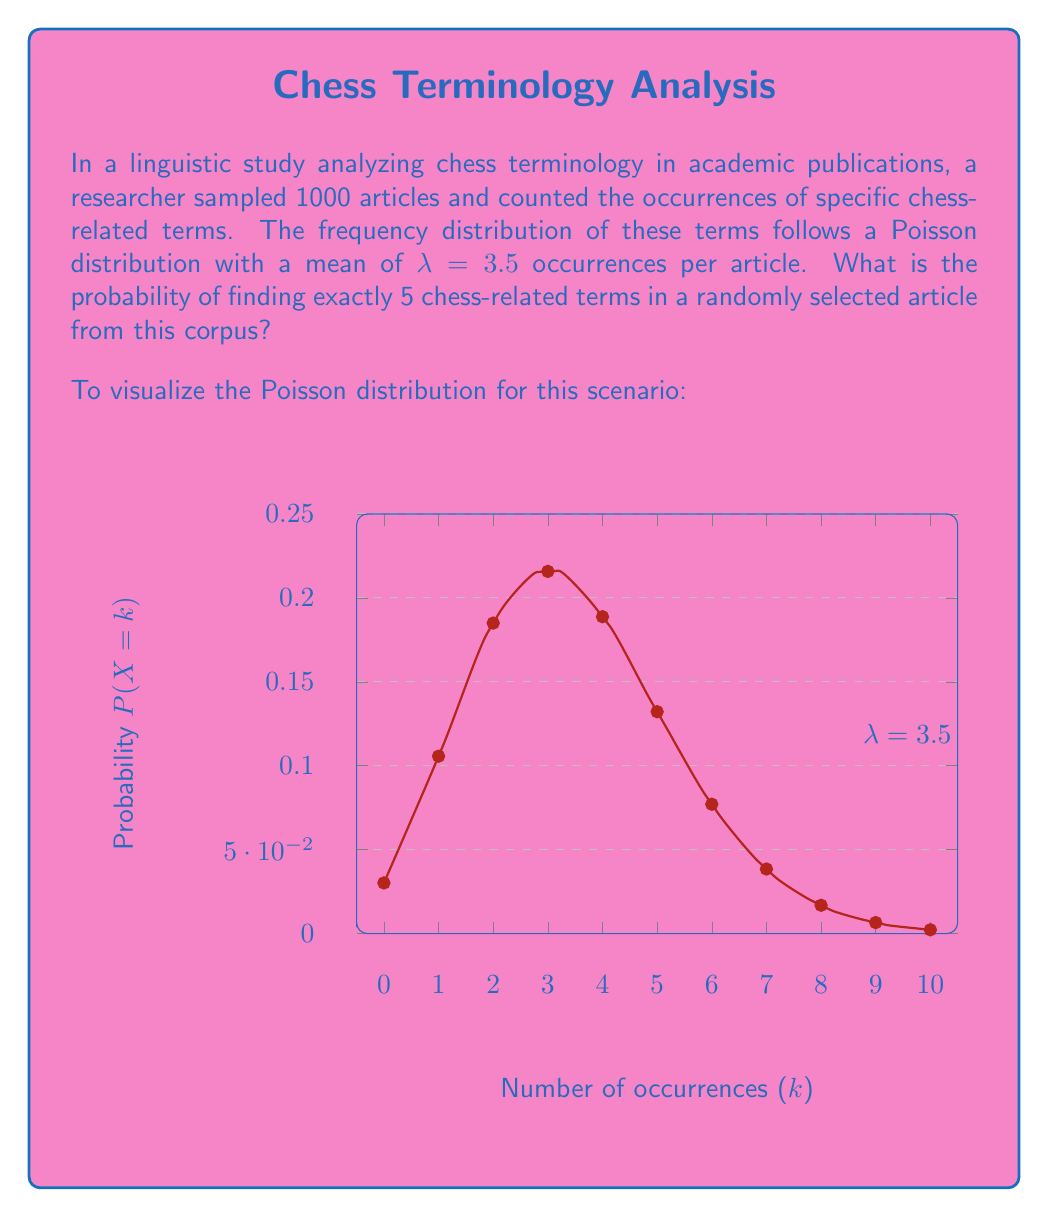Show me your answer to this math problem. To solve this problem, we'll use the Poisson probability mass function:

$$P(X = k) = \frac{e^{-\lambda} \lambda^k}{k!}$$

Where:
- $\lambda$ is the average number of occurrences (mean of the Poisson distribution)
- $k$ is the number of occurrences we're interested in
- $e$ is Euler's number (approximately 2.71828)

Given:
- $\lambda = 3.5$ (mean occurrences per article)
- $k = 5$ (we're looking for exactly 5 occurrences)

Let's substitute these values into the formula:

$$P(X = 5) = \frac{e^{-3.5} 3.5^5}{5!}$$

Now, let's calculate step by step:

1) First, calculate $e^{-3.5}$:
   $e^{-3.5} \approx 0.0302619$

2) Calculate $3.5^5$:
   $3.5^5 = 525.21875$

3) Calculate $5!$:
   $5! = 5 \times 4 \times 3 \times 2 \times 1 = 120$

4) Now, put it all together:
   $$P(X = 5) = \frac{0.0302619 \times 525.21875}{120}$$

5) Simplify:
   $$P(X = 5) \approx 0.1317224$$

Therefore, the probability of finding exactly 5 chess-related terms in a randomly selected article is approximately 0.1317 or 13.17%.
Answer: 0.1317 